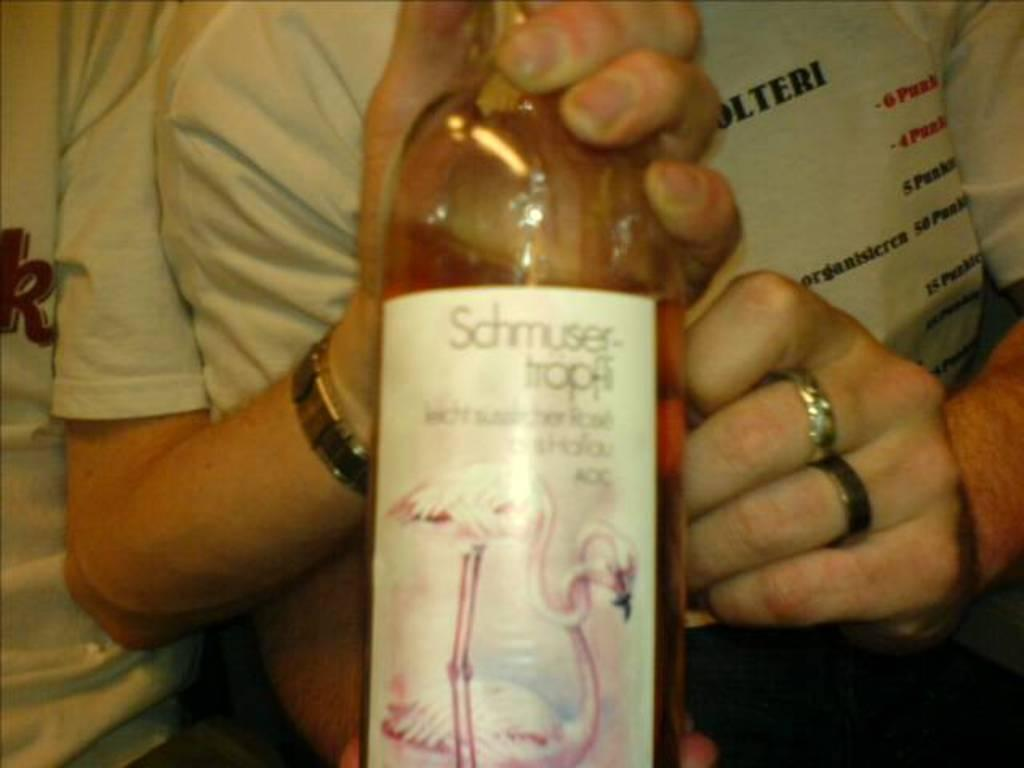<image>
Write a terse but informative summary of the picture. Person holding a bottle with a label that says "Schmuser-Tropfi". 